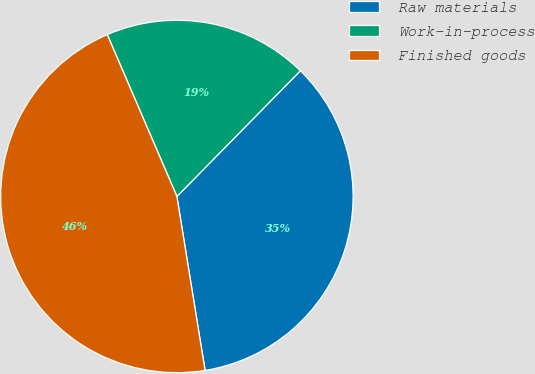Convert chart. <chart><loc_0><loc_0><loc_500><loc_500><pie_chart><fcel>Raw materials<fcel>Work-in-process<fcel>Finished goods<nl><fcel>35.09%<fcel>18.82%<fcel>46.09%<nl></chart> 